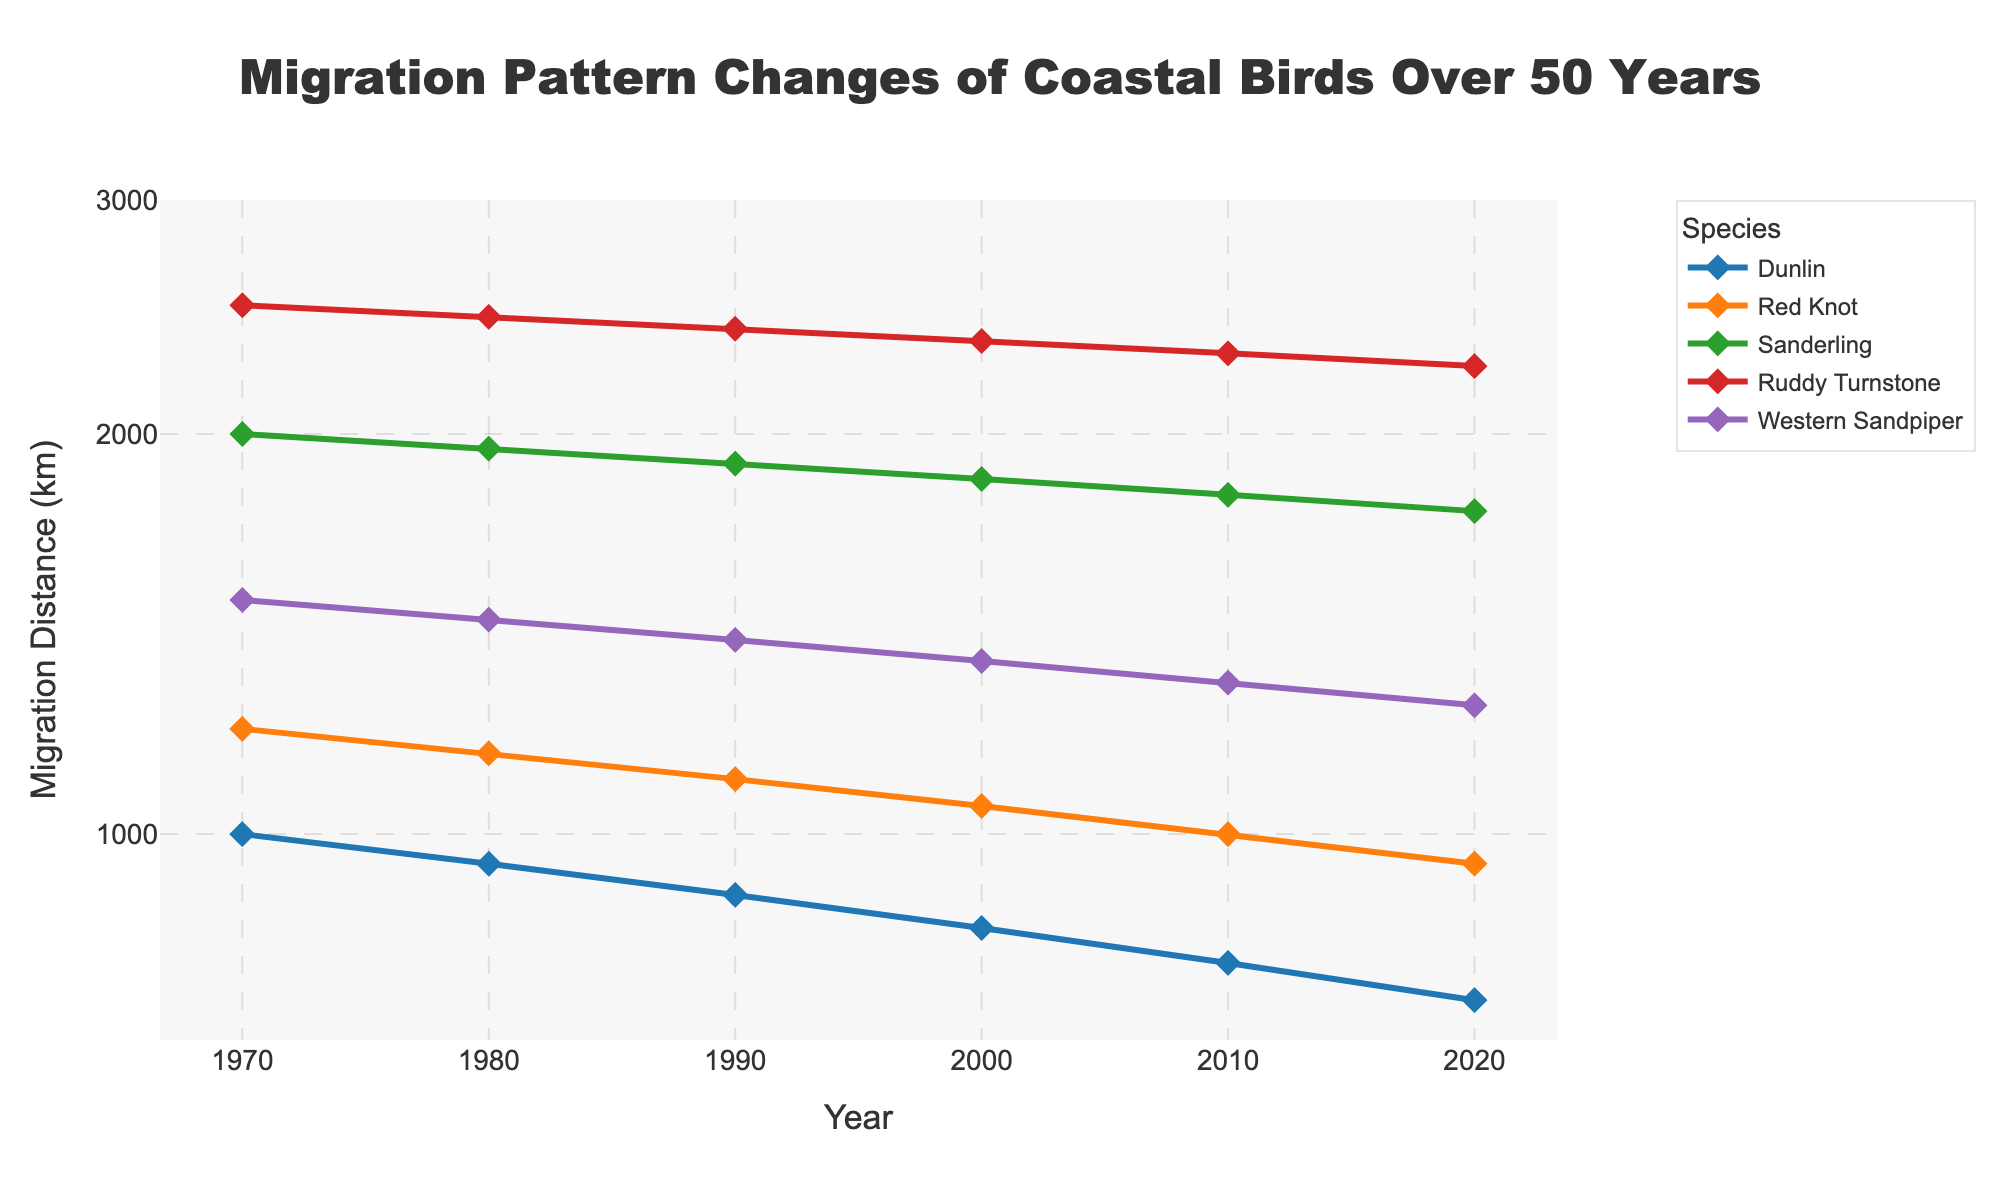Which species has the longest migration distance in 1970? By looking at the points for each species in 1970, the Ruddy Turnstone has the highest migration distance.
Answer: Ruddy Turnstone How has the migration distance of the Dunlin changed between 1970 and 2020? The migration distance for the Dunlin has decreased from 1000 km in 1970 to 750 km in 2020.
Answer: Decreased by 250 km Which species shows the smallest decrease in migration distance over the 50-year period? By comparing the change in migration distance for each species, Red Knot shows the smallest decrease, from 1200 km in 1970 to 950 km in 2020.
Answer: Red Knot What is the range of years displayed on the x-axis? The x-axis displays years from 1970 to 2020.
Answer: 1970 to 2020 Compare the migration distance trends of the Sanderling and the Western Sandpiper. Which species showed a greater reduction by 2020? By comparing the end points for both species, the Sanderling's migration distance decreased from 2000 km to 1750 km (250 km reduction), and the Western Sandpiper's decreased from 1500 km to 1250 km (250 km reduction). Both species showed the same reduction.
Answer: Both species showed the same reduction How does the y-axis scale affect the visual interpretation of the migration distances? The y-axis uses a logarithmic scale, which means equal distances on the axis represent multiplicative changes. This makes it easier to compare proportionate changes, even if the absolute distances are different.
Answer: Logarithmic scale What pattern can be observed in the migration distances of coastal birds from 1970 to 2020? All species show a consistent decrease in migration distances over the 50 years.
Answer: Decreasing trend Which species had the highest migration distance in 2020? In 2020, Ruddy Turnstone, with a migration distance of 2250 km, has the highest migration distance among the species listed.
Answer: Ruddy Turnstone What is the title of the figure, and what information does it provide? The title is "Migration Pattern Changes of Coastal Birds Over 50 Years." It indicates the figure is about how the migration distances of various coastal bird species have changed from 1970 to 2020.
Answer: Migration Pattern Changes of Coastal Birds Over 50 Years How does the migration distance of the Red Knot in 2000 compare to the Dunlin in 2020? In 2000, the Red Knot's migration distance was 1050 km, whereas the Dunlin’s in 2020 was 750 km. The Red Knot in 2000 had a longer migration distance compared to the Dunlin in 2020.
Answer: Red Knot had a longer migration distance 